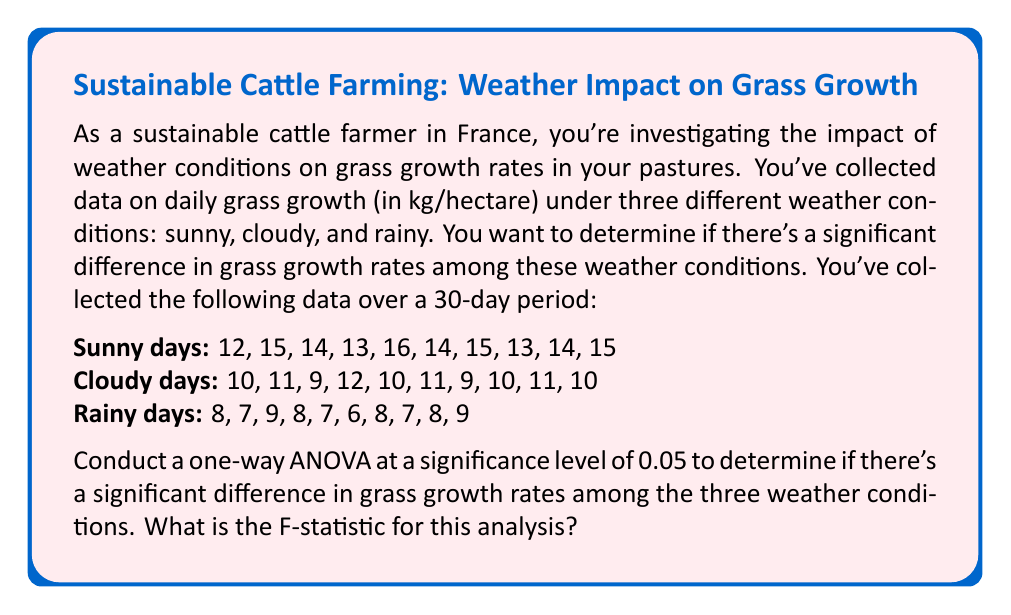Show me your answer to this math problem. To conduct a one-way ANOVA, we need to follow these steps:

1. Calculate the means for each group and the overall mean:
   Sunny mean: $\bar{X}_s = 14.1$
   Cloudy mean: $\bar{X}_c = 10.3$
   Rainy mean: $\bar{X}_r = 7.7$
   Overall mean: $\bar{X} = 10.7$

2. Calculate the Sum of Squares Between groups (SSB):
   $$SSB = n_s(\bar{X}_s - \bar{X})^2 + n_c(\bar{X}_c - \bar{X})^2 + n_r(\bar{X}_r - \bar{X})^2$$
   $$SSB = 10(14.1 - 10.7)^2 + 10(10.3 - 10.7)^2 + 10(7.7 - 10.7)^2 = 252.2$$

3. Calculate the Sum of Squares Within groups (SSW):
   $$SSW = \sum_{i=1}^{n_s} (X_{si} - \bar{X}_s)^2 + \sum_{i=1}^{n_c} (X_{ci} - \bar{X}_c)^2 + \sum_{i=1}^{n_r} (X_{ri} - \bar{X}_r)^2$$
   $$SSW = 16.9 + 10.1 + 10.1 = 37.1$$

4. Calculate the degrees of freedom:
   df between groups (dfB) = number of groups - 1 = 3 - 1 = 2
   df within groups (dfW) = total observations - number of groups = 30 - 3 = 27

5. Calculate the Mean Square Between (MSB) and Mean Square Within (MSW):
   $$MSB = \frac{SSB}{dfB} = \frac{252.2}{2} = 126.1$$
   $$MSW = \frac{SSW}{dfW} = \frac{37.1}{27} = 1.37407$$

6. Calculate the F-statistic:
   $$F = \frac{MSB}{MSW} = \frac{126.1}{1.37407} = 91.77$$

The F-statistic for this analysis is approximately 91.77.
Answer: 91.77 